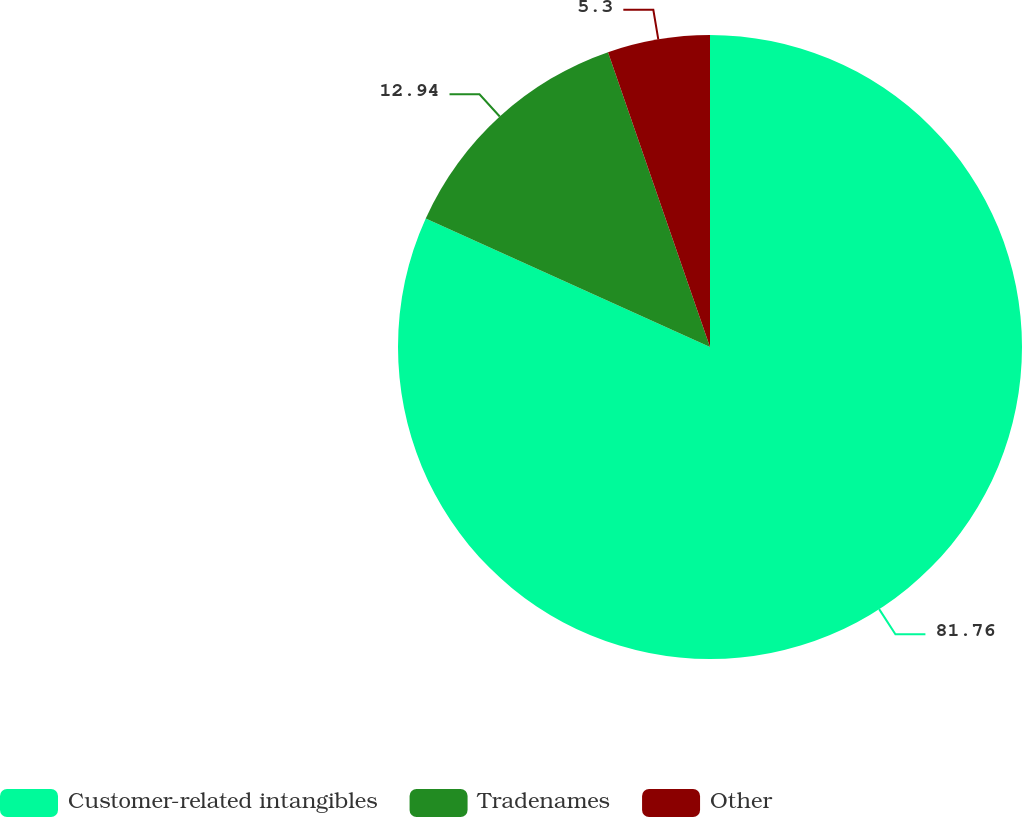<chart> <loc_0><loc_0><loc_500><loc_500><pie_chart><fcel>Customer-related intangibles<fcel>Tradenames<fcel>Other<nl><fcel>81.76%<fcel>12.94%<fcel>5.3%<nl></chart> 